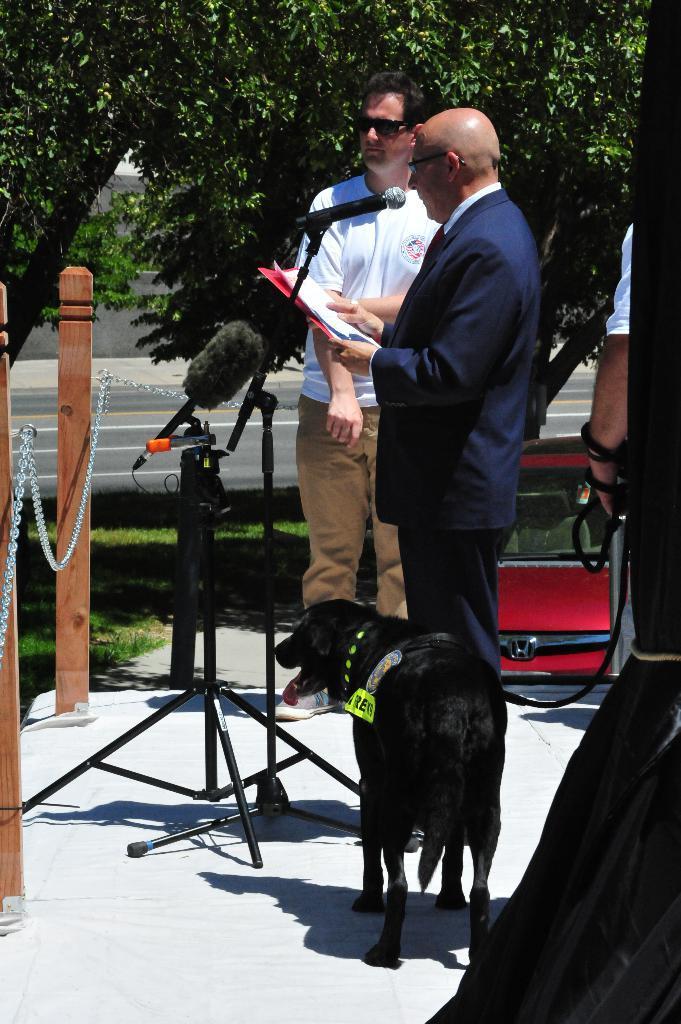Describe this image in one or two sentences. In this image there are two men standing on the stage, there is a man holding an object, there are stands, there are microphones, there is a person's hand towards the right of the image, there is a curtain towards the right of the image, there is a fence towards the left of the image, there is grass, there is a road, there is a wall, there is a car, there are trees towards the top of the image. 